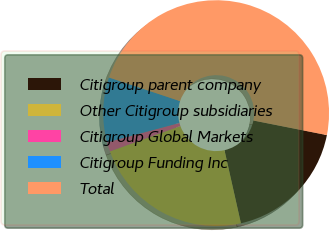Convert chart to OTSL. <chart><loc_0><loc_0><loc_500><loc_500><pie_chart><fcel>Citigroup parent company<fcel>Other Citigroup subsidiaries<fcel>Citigroup Global Markets<fcel>Citigroup Funding Inc<fcel>Total<nl><fcel>18.36%<fcel>23.02%<fcel>1.34%<fcel>9.27%<fcel>48.01%<nl></chart> 